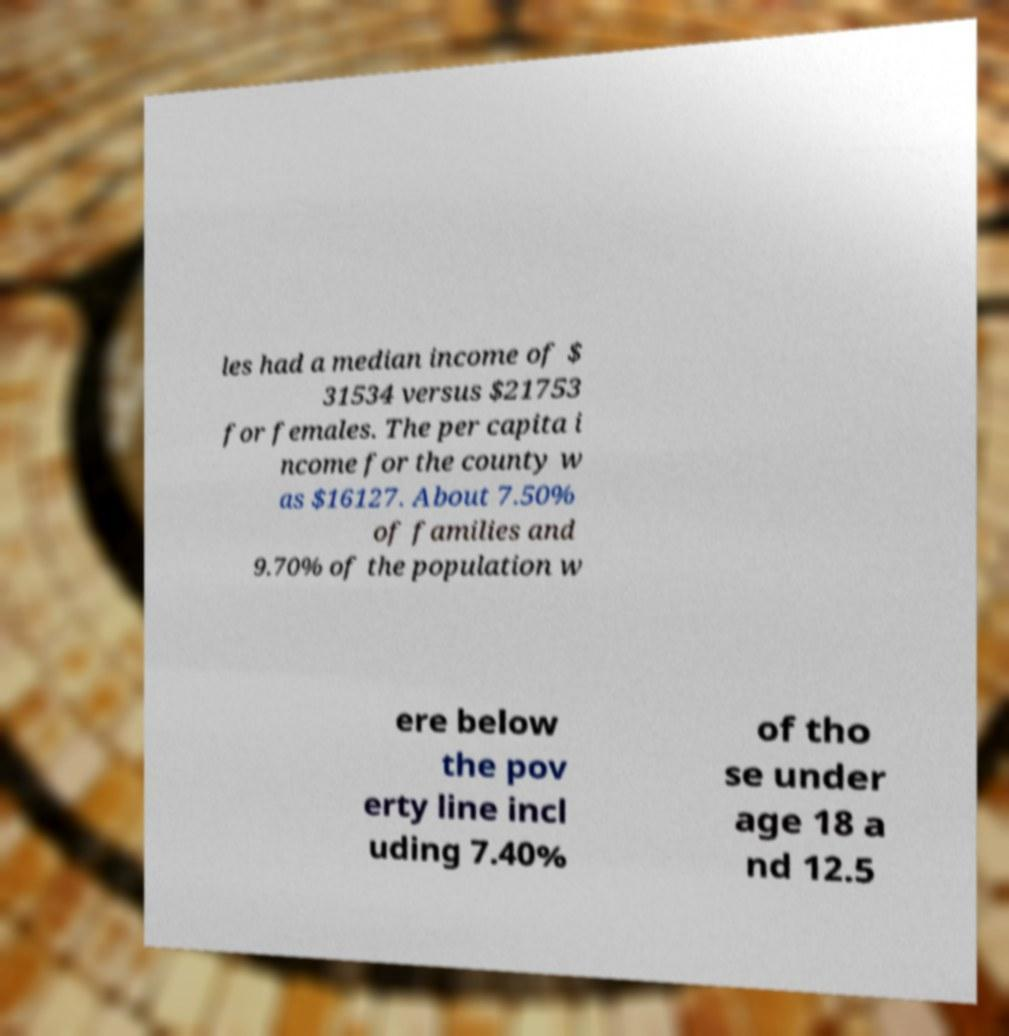Please identify and transcribe the text found in this image. les had a median income of $ 31534 versus $21753 for females. The per capita i ncome for the county w as $16127. About 7.50% of families and 9.70% of the population w ere below the pov erty line incl uding 7.40% of tho se under age 18 a nd 12.5 